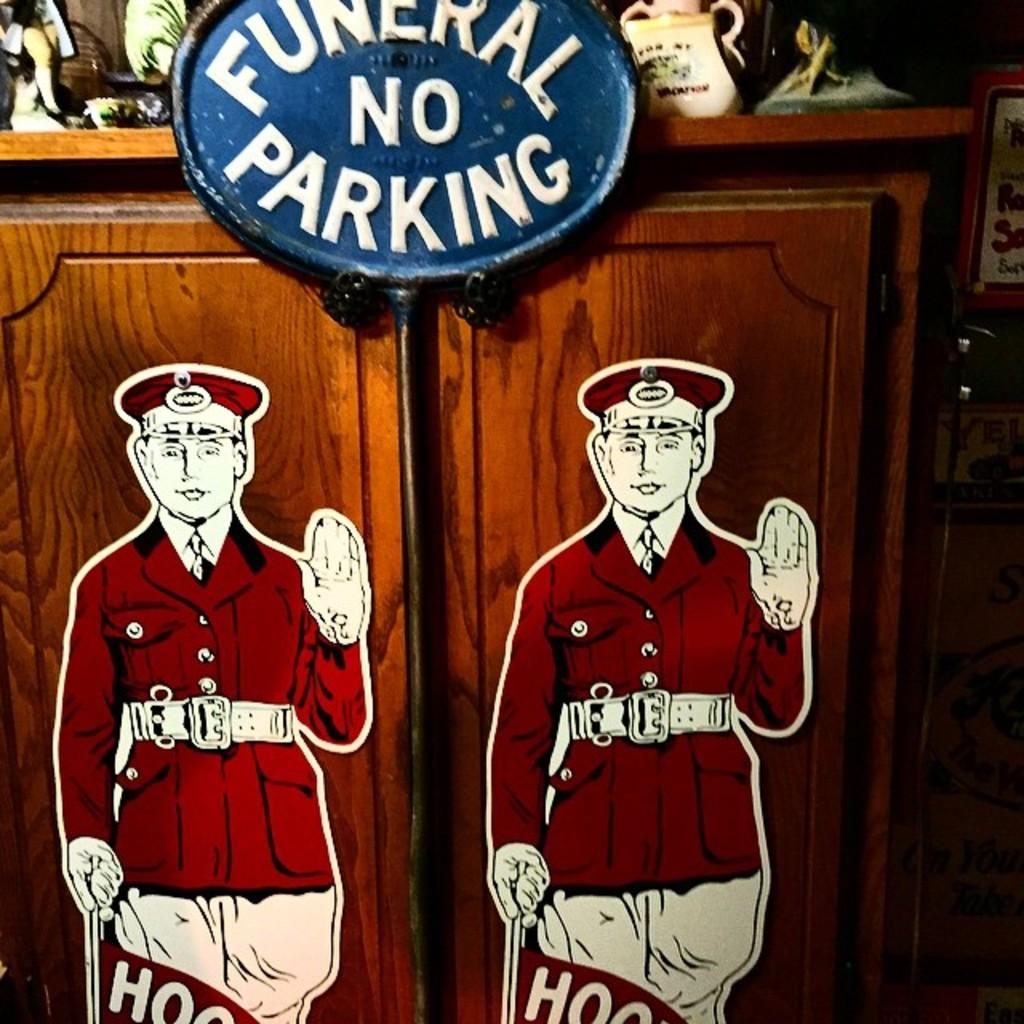Provide a one-sentence caption for the provided image. Funeral no parking sign in blue on a cabinet. 